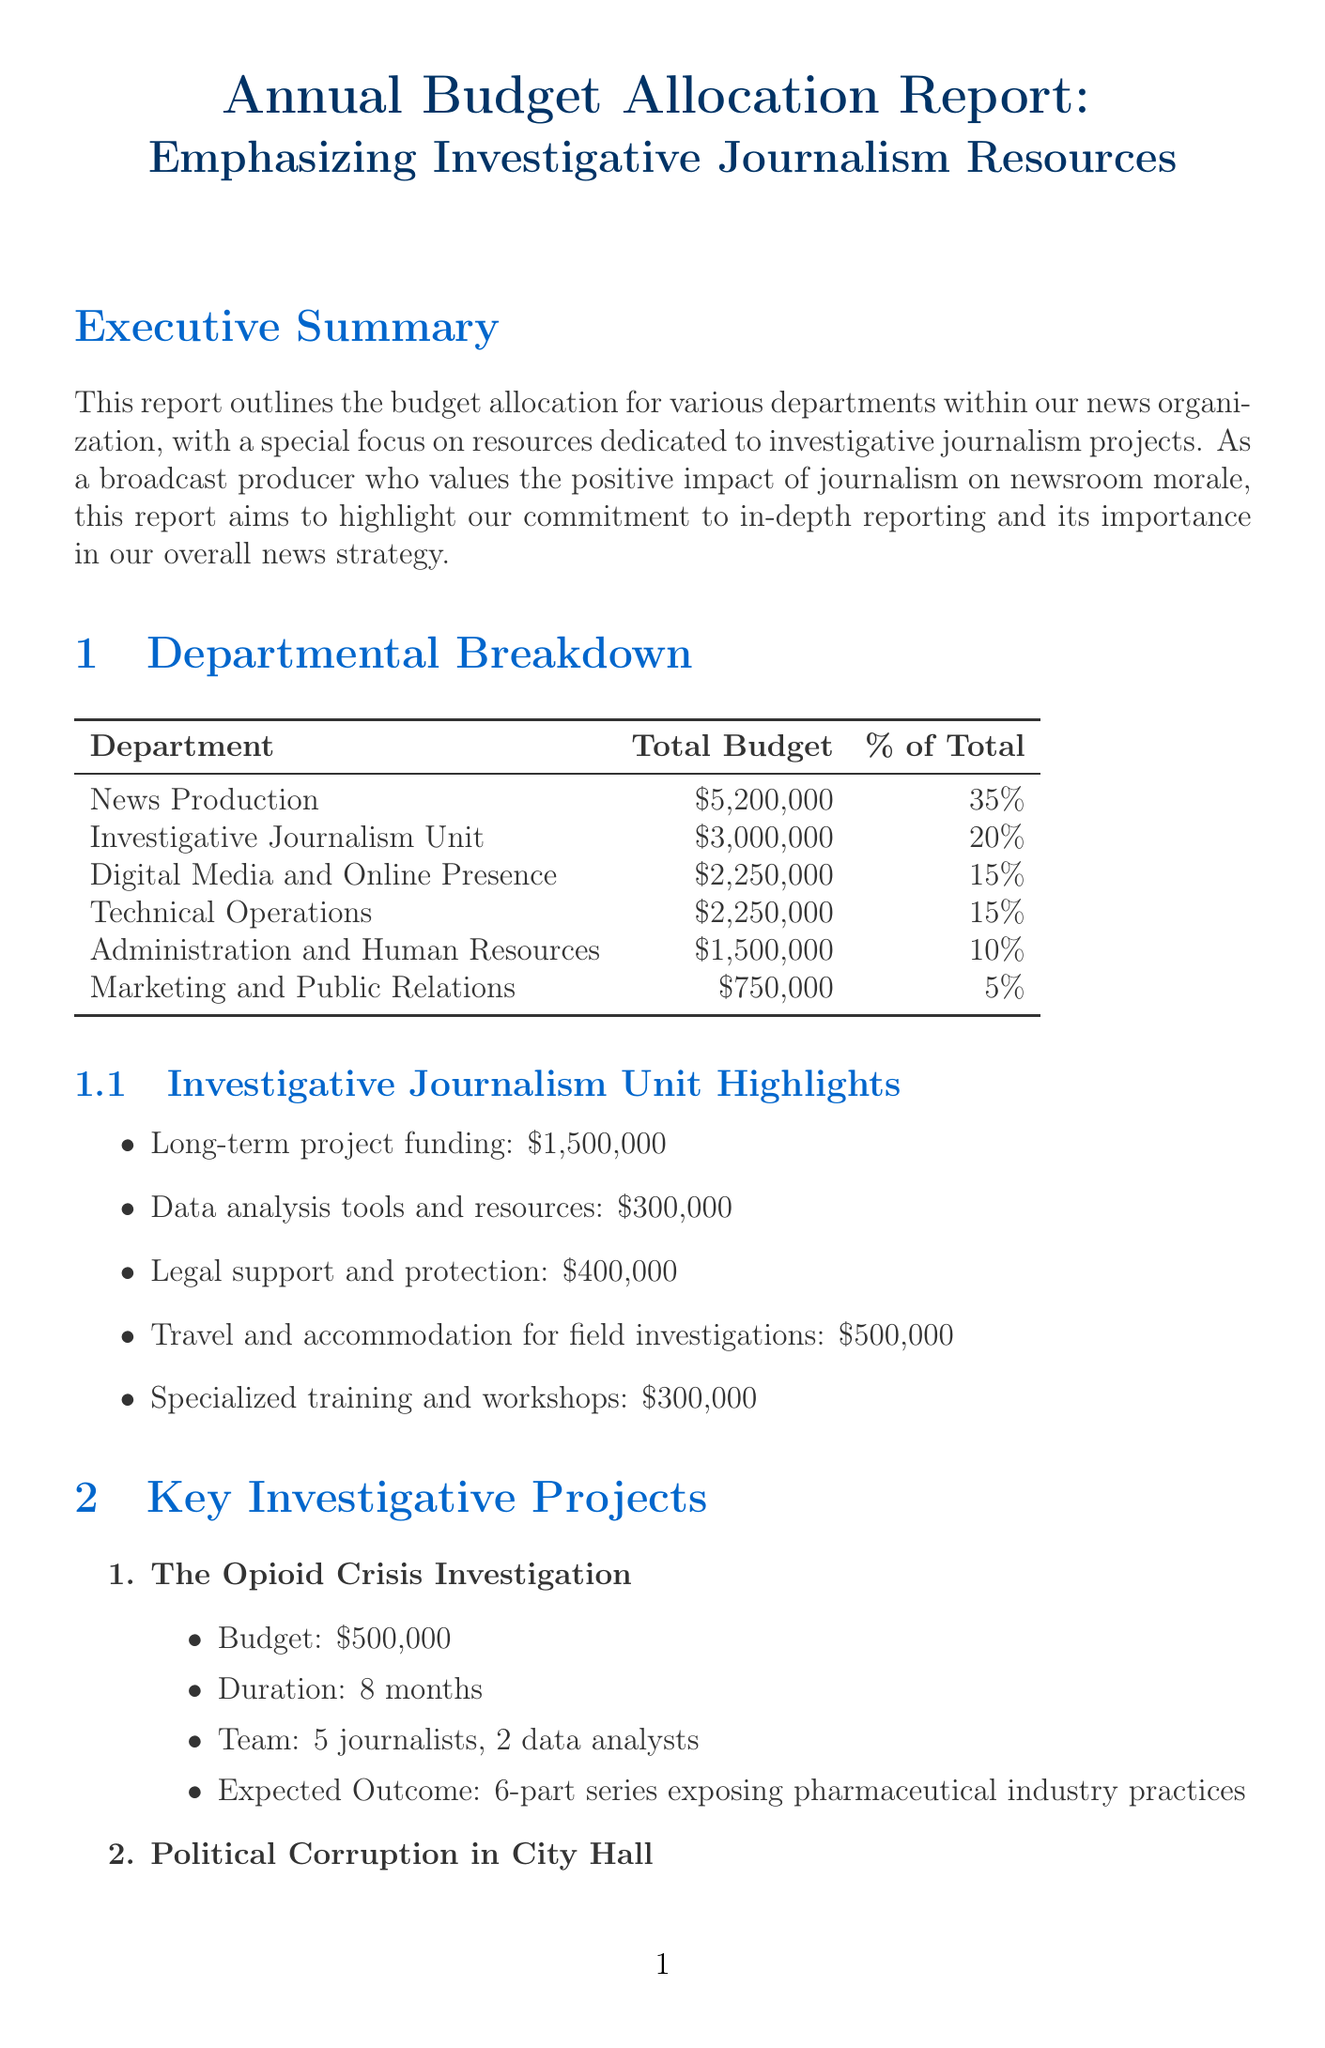What is the total budget for the Investigative Journalism Unit? The total budget for the Investigative Journalism Unit is specified in the document.
Answer: $3,000,000 What percentage of the total budget is allocated to News Production? The percentage of the total budget allocated to News Production is listed in the departmental breakdown.
Answer: 35% How many journalists are involved in the Opioid Crisis Investigation project? The document provides the team size for the Opioid Crisis Investigation project.
Answer: 5 journalists What is the budget for legal support and protection in the Investigative Journalism Unit? The budget for legal support and protection is included in the key allocations for the Investigative Journalism Unit.
Answer: $400,000 What is one of the stated benefits of focusing on investigative journalism for newsroom morale? The document lists several impacts on newsroom morale.
Answer: Increased job satisfaction due to meaningful work What challenge is related to resource allocation between daily news and investigations? The challenges section specifies this challenge regarding balancing resources.
Answer: Balancing resources between daily news coverage and long-term investigations How long will the Climate Change Impact on Local Communities project last? The duration of the Climate Change Impact on Local Communities project is mentioned in the project details.
Answer: 4 months What is the expected outcome of the Political Corruption in City Hall investigation? The document describes the expected outcome for the Political Corruption in City Hall investigation.
Answer: Revealing report on misuse of public funds and potential criminal charges 